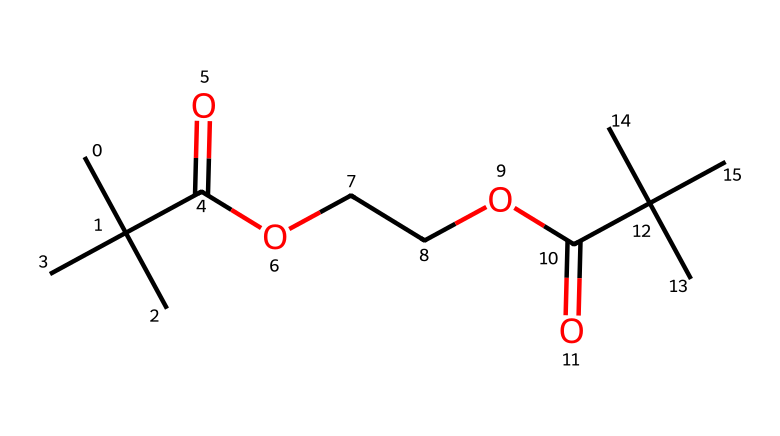how many carbon atoms are present in this polymer? By examining the provided SMILES representation, we can count all the carbon (C) atoms. The structure suggests there are 12 carbon atoms in total as inferred from the arrangement.
Answer: 12 what functional groups are present in the polymer? Analyzing the SMILES reveals the presence of carboxylic acid groups (C(=O)O) and ester groups (C(=O)OCC). These are characteristic functional groups that contribute to the properties of the polymer.
Answer: carboxylic acid and ester what is the degree of polymerization implied by the structure? The degree of polymerization can be understood as the number of repeating units within the polymer. Due to the presence of ester linkages and branching indicated in the SMILES, we derive that it is mainly linear with a degree of polymerization suggesting multiple repeat units, typically 2-3 for such structures.
Answer: 2-3 considering the structure, does this polymer exhibit hydrophilicity or hydrophobicity? The presence of ester and carboxylic acid functional groups suggests that the polymer has polar regions that interact favorably with water, thus leaning towards hydrophilicity. This is supported by the functional groups that can form hydrogen bonds with water.
Answer: hydrophilicity what type of polymerization is implied in the forming of this plastic? The structure of the polymer indicates that it is formed through condensation polymerization, evident from the ester linkages arising from the reaction between carboxylic acids and alcohols, leading to small molecules such as water being formed in the process.
Answer: condensation polymerization is this polymer biodegradable? The presence of both carboxylic acid and ester groups allows the polymer to be susceptible to hydrolysis and microbial degradation, confirming its degradation potential under suitable environmental conditions.
Answer: biodegradable 